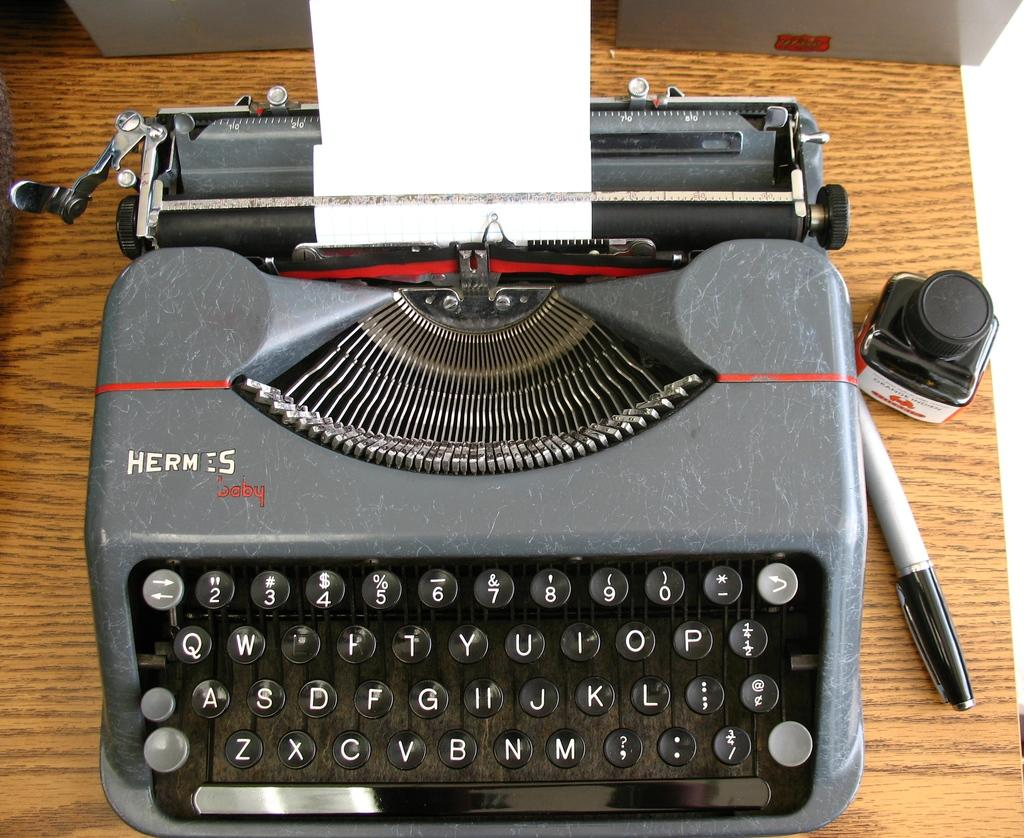<image>
Present a compact description of the photo's key features. A gray Hermes mechanical typewriter with a narrow sheet of paper in the rollers. 